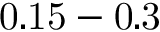<formula> <loc_0><loc_0><loc_500><loc_500>0 . 1 5 - 0 . 3</formula> 